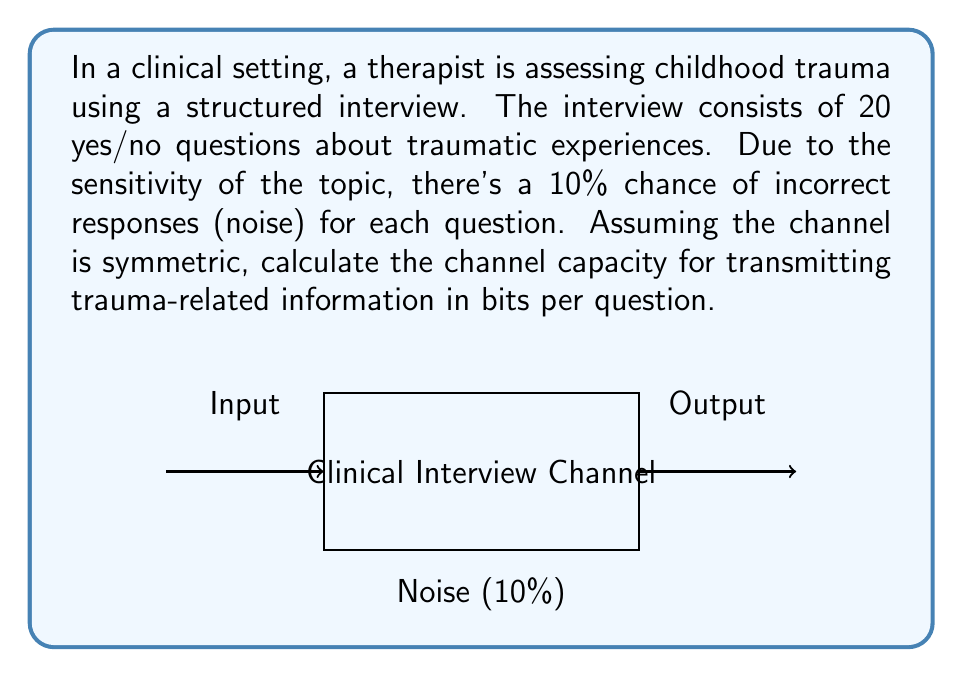Solve this math problem. To solve this problem, we'll use the binary symmetric channel (BSC) model and the channel capacity formula for BSC. Let's proceed step-by-step:

1) In a BSC, the crossover probability $p$ represents the probability of an error. Here, $p = 0.10$ (10% chance of incorrect responses).

2) The channel capacity $C$ for a BSC is given by:

   $$C = 1 - H(p)$$

   where $H(p)$ is the binary entropy function.

3) The binary entropy function is defined as:

   $$H(p) = -p \log_2(p) - (1-p) \log_2(1-p)$$

4) Let's calculate $H(p)$:
   
   $$\begin{align}
   H(0.10) &= -0.10 \log_2(0.10) - 0.90 \log_2(0.90) \\
   &\approx 0.10 \times 3.32 + 0.90 \times 0.15 \\
   &\approx 0.332 + 0.135 \\
   &\approx 0.467
   \end{align}$$

5) Now we can calculate the channel capacity:

   $$\begin{align}
   C &= 1 - H(p) \\
   &= 1 - 0.467 \\
   &\approx 0.533 \text{ bits per question}
   \end{align}$$

This means that for each yes/no question in the trauma assessment, approximately 0.533 bits of information can be reliably transmitted through the channel, taking into account the noise introduced by potential incorrect responses.
Answer: $0.533 \text{ bits per question}$ 